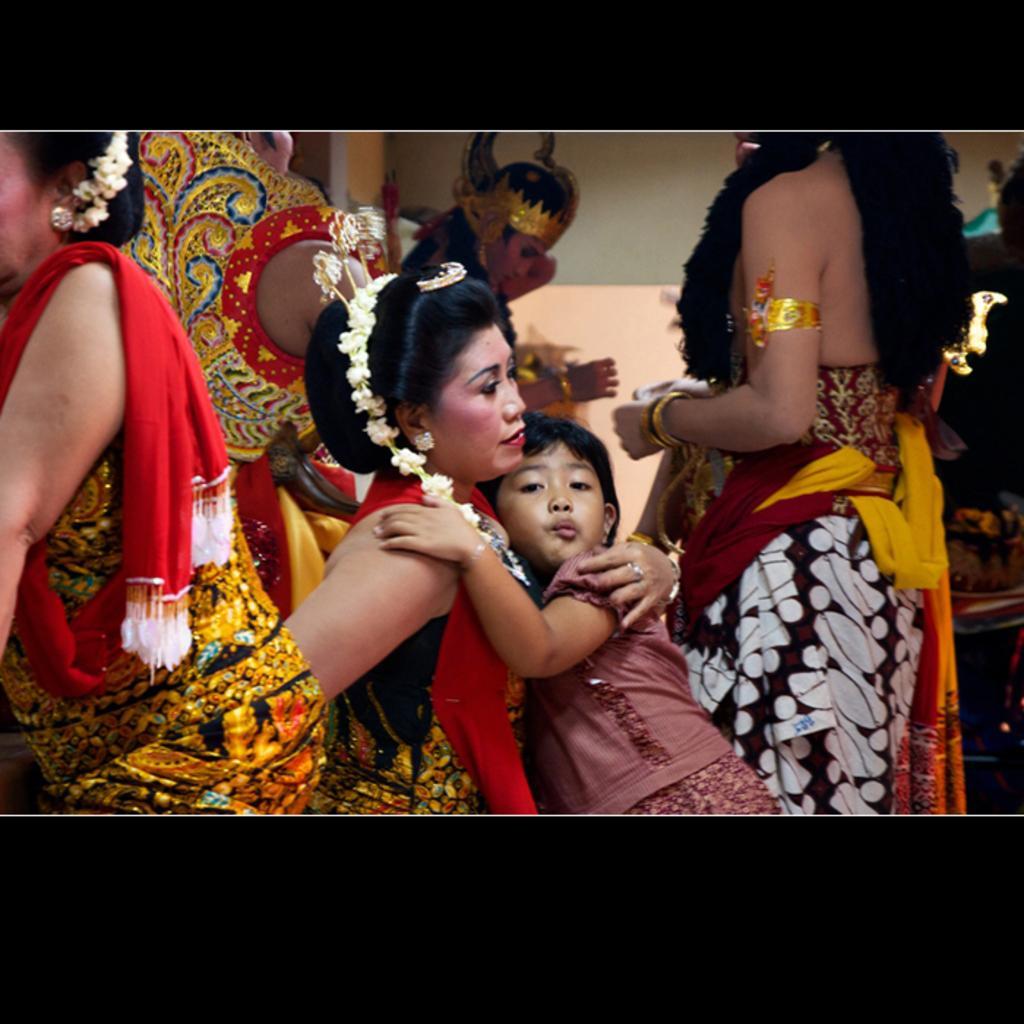Please provide a concise description of this image. In this image we can see some group of persons wearing different costumes standing and some are sitting. 